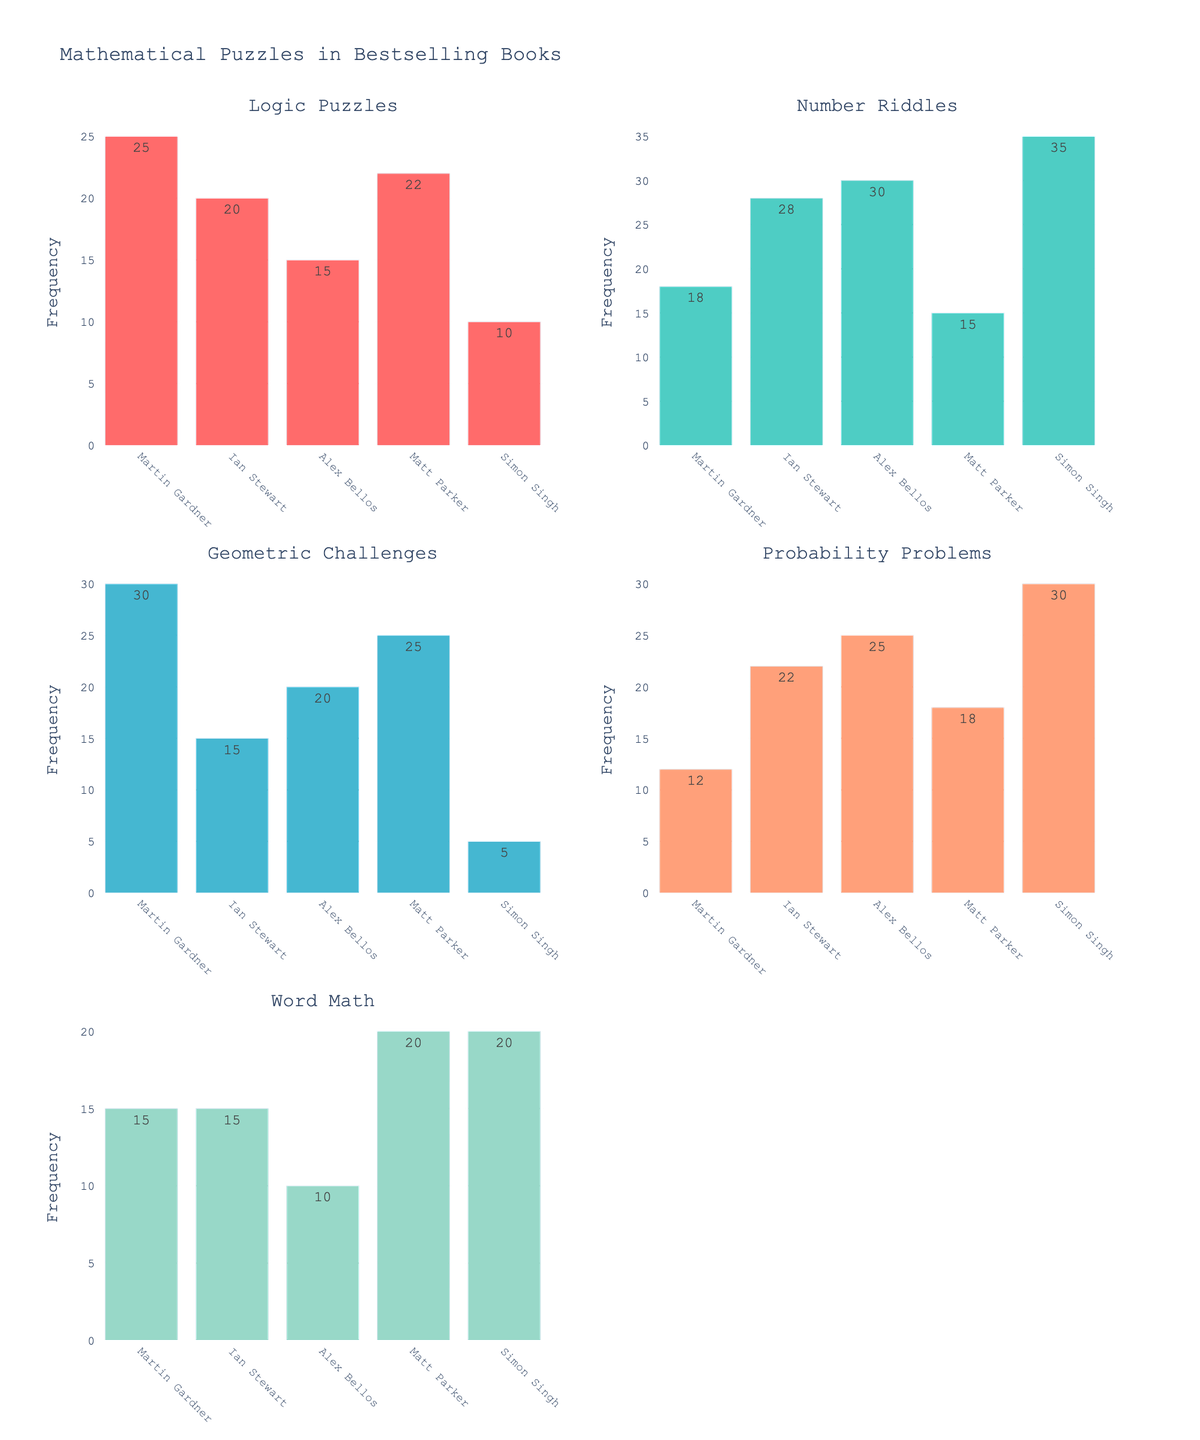What is the title of the figure? The title of the figure can usually be found at the top and it is meant to provide an overall summary of what the data visualizations represent.
Answer: Annual Rainfall Patterns in Different Regions of Africa Which region experiences the highest rainfall in January? By looking at the first bar (January) in each subplot, we see that Madagascar has the tallest bar, indicating the highest rainfall.
Answer: Madagascar How many regions experience zero rainfall in June? Check the bars for June in each subplot and count how many are at the bottom, indicating zero value. Namib Desert, Nile Delta, and Sahel all have zero rainfall.
Answer: 3 Which month has the maximum rainfall in the Congo Basin region? Look at the bars in the Congo Basin subplot. The one with the highest bar will represent the month with maximum rainfall.
Answer: March What is the total rainfall in the East African Highlands for the first half of the year (Jan-Jun)? Add up the rainfall values for the months January through June for East African Highlands: 50 + 60 + 120 + 180 + 120 + 30 = 560 mm.
Answer: 560 mm Which region has a more even distribution of rainfall throughout the year, Congo Basin or Nile Delta? By comparing the bar heights across all months for both subplots, notice that Congo Basin's bars are more evenly spread out, whereas Nile Delta's bars have large differences.
Answer: Congo Basin How does the rainfall in August compare between the Sahel and Namib Desert regions? Compare the bar heights for August in the Sahel and Namib Desert subplots. Sahel has a significantly taller bar than Namib Desert.
Answer: Sahel has more rainfall Which two regions have the highest peak rainfall values, and in which months do they occur? Identify the highest bars in all subplots. Madagascar has its highest bar in January, and Congo Basin in March.
Answer: Madagascar in January, Congo Basin in March What is the average rainfall in the Nile Delta from November to January? Add the rainfall values for November, December, and January in the Nile Delta: 10 + 15 + 15 = 40 mm, then divide by 3 for the average. 40 / 3 ≈ 13.33 mm.
Answer: 13.33 mm In which month does the Namib Desert receive its maximum rainfall, and how much is it? Look at the Namib Desert subplot and find the highest bar. The highest is in April with 10 mm of rainfall.
Answer: April, 10 mm 